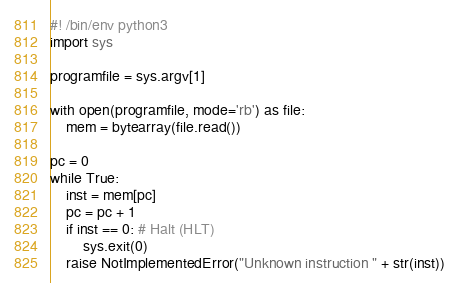<code> <loc_0><loc_0><loc_500><loc_500><_Python_>#! /bin/env python3
import sys

programfile = sys.argv[1]

with open(programfile, mode='rb') as file:
    mem = bytearray(file.read())

pc = 0
while True:
    inst = mem[pc]
    pc = pc + 1
    if inst == 0: # Halt (HLT)
        sys.exit(0)
    raise NotImplementedError("Unknown instruction " + str(inst))
</code> 